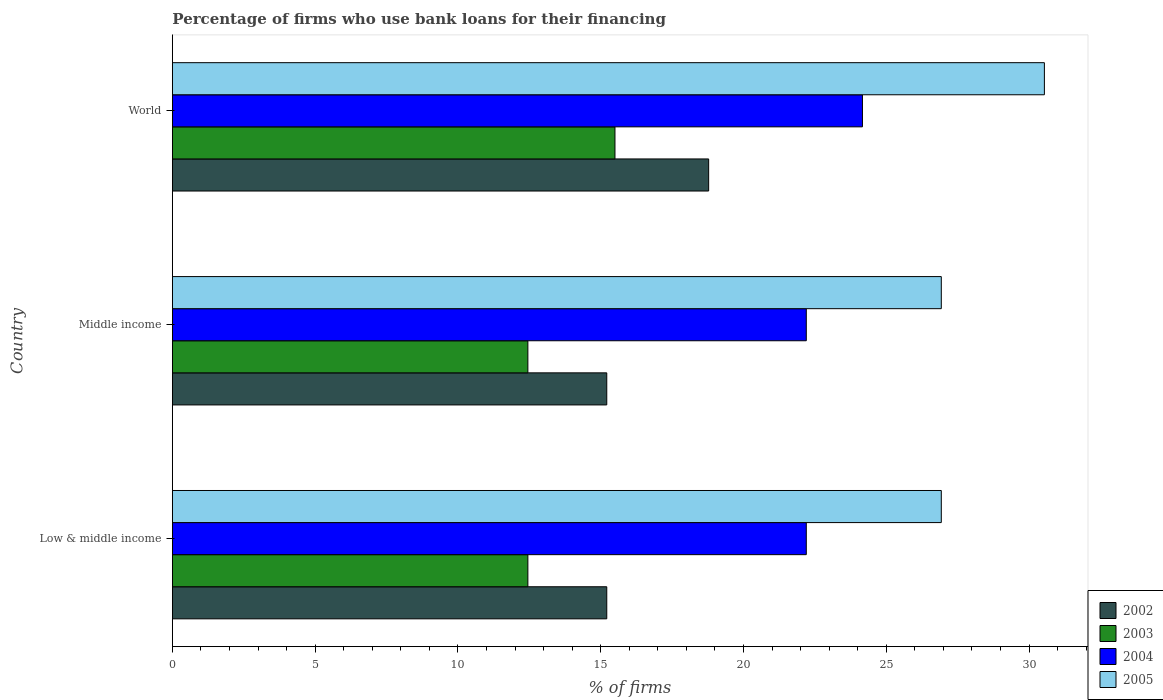How many different coloured bars are there?
Provide a short and direct response. 4. How many groups of bars are there?
Your answer should be very brief. 3. What is the label of the 2nd group of bars from the top?
Ensure brevity in your answer.  Middle income. What is the percentage of firms who use bank loans for their financing in 2002 in Middle income?
Make the answer very short. 15.21. Across all countries, what is the maximum percentage of firms who use bank loans for their financing in 2005?
Keep it short and to the point. 30.54. Across all countries, what is the minimum percentage of firms who use bank loans for their financing in 2003?
Your response must be concise. 12.45. In which country was the percentage of firms who use bank loans for their financing in 2002 maximum?
Keep it short and to the point. World. What is the total percentage of firms who use bank loans for their financing in 2005 in the graph?
Provide a succinct answer. 84.39. What is the difference between the percentage of firms who use bank loans for their financing in 2003 in Middle income and that in World?
Your answer should be compact. -3.05. What is the difference between the percentage of firms who use bank loans for their financing in 2002 in World and the percentage of firms who use bank loans for their financing in 2003 in Low & middle income?
Make the answer very short. 6.33. What is the average percentage of firms who use bank loans for their financing in 2002 per country?
Your answer should be compact. 16.4. What is the difference between the percentage of firms who use bank loans for their financing in 2002 and percentage of firms who use bank loans for their financing in 2004 in World?
Keep it short and to the point. -5.39. In how many countries, is the percentage of firms who use bank loans for their financing in 2004 greater than 17 %?
Keep it short and to the point. 3. What is the ratio of the percentage of firms who use bank loans for their financing in 2002 in Low & middle income to that in World?
Give a very brief answer. 0.81. Is the percentage of firms who use bank loans for their financing in 2005 in Low & middle income less than that in World?
Offer a terse response. Yes. Is the difference between the percentage of firms who use bank loans for their financing in 2002 in Low & middle income and Middle income greater than the difference between the percentage of firms who use bank loans for their financing in 2004 in Low & middle income and Middle income?
Your response must be concise. No. What is the difference between the highest and the second highest percentage of firms who use bank loans for their financing in 2003?
Make the answer very short. 3.05. What is the difference between the highest and the lowest percentage of firms who use bank loans for their financing in 2005?
Keep it short and to the point. 3.61. Is the sum of the percentage of firms who use bank loans for their financing in 2002 in Middle income and World greater than the maximum percentage of firms who use bank loans for their financing in 2005 across all countries?
Ensure brevity in your answer.  Yes. Is it the case that in every country, the sum of the percentage of firms who use bank loans for their financing in 2003 and percentage of firms who use bank loans for their financing in 2004 is greater than the sum of percentage of firms who use bank loans for their financing in 2002 and percentage of firms who use bank loans for their financing in 2005?
Ensure brevity in your answer.  No. Is it the case that in every country, the sum of the percentage of firms who use bank loans for their financing in 2002 and percentage of firms who use bank loans for their financing in 2005 is greater than the percentage of firms who use bank loans for their financing in 2004?
Offer a very short reply. Yes. How many bars are there?
Offer a terse response. 12. How many countries are there in the graph?
Provide a short and direct response. 3. What is the difference between two consecutive major ticks on the X-axis?
Your answer should be very brief. 5. Does the graph contain any zero values?
Your response must be concise. No. Does the graph contain grids?
Provide a short and direct response. No. Where does the legend appear in the graph?
Keep it short and to the point. Bottom right. How are the legend labels stacked?
Offer a terse response. Vertical. What is the title of the graph?
Ensure brevity in your answer.  Percentage of firms who use bank loans for their financing. What is the label or title of the X-axis?
Your answer should be compact. % of firms. What is the % of firms in 2002 in Low & middle income?
Offer a very short reply. 15.21. What is the % of firms in 2003 in Low & middle income?
Make the answer very short. 12.45. What is the % of firms in 2004 in Low & middle income?
Provide a succinct answer. 22.2. What is the % of firms of 2005 in Low & middle income?
Provide a succinct answer. 26.93. What is the % of firms in 2002 in Middle income?
Your answer should be compact. 15.21. What is the % of firms in 2003 in Middle income?
Make the answer very short. 12.45. What is the % of firms in 2005 in Middle income?
Make the answer very short. 26.93. What is the % of firms of 2002 in World?
Your response must be concise. 18.78. What is the % of firms of 2004 in World?
Your answer should be very brief. 24.17. What is the % of firms of 2005 in World?
Offer a very short reply. 30.54. Across all countries, what is the maximum % of firms of 2002?
Keep it short and to the point. 18.78. Across all countries, what is the maximum % of firms of 2004?
Offer a terse response. 24.17. Across all countries, what is the maximum % of firms of 2005?
Give a very brief answer. 30.54. Across all countries, what is the minimum % of firms in 2002?
Offer a very short reply. 15.21. Across all countries, what is the minimum % of firms of 2003?
Your answer should be very brief. 12.45. Across all countries, what is the minimum % of firms in 2004?
Provide a short and direct response. 22.2. Across all countries, what is the minimum % of firms of 2005?
Your response must be concise. 26.93. What is the total % of firms in 2002 in the graph?
Your answer should be compact. 49.21. What is the total % of firms in 2003 in the graph?
Your response must be concise. 40.4. What is the total % of firms in 2004 in the graph?
Your answer should be compact. 68.57. What is the total % of firms in 2005 in the graph?
Offer a very short reply. 84.39. What is the difference between the % of firms of 2003 in Low & middle income and that in Middle income?
Give a very brief answer. 0. What is the difference between the % of firms in 2002 in Low & middle income and that in World?
Offer a very short reply. -3.57. What is the difference between the % of firms in 2003 in Low & middle income and that in World?
Keep it short and to the point. -3.05. What is the difference between the % of firms in 2004 in Low & middle income and that in World?
Ensure brevity in your answer.  -1.97. What is the difference between the % of firms in 2005 in Low & middle income and that in World?
Provide a succinct answer. -3.61. What is the difference between the % of firms of 2002 in Middle income and that in World?
Offer a very short reply. -3.57. What is the difference between the % of firms of 2003 in Middle income and that in World?
Offer a terse response. -3.05. What is the difference between the % of firms of 2004 in Middle income and that in World?
Make the answer very short. -1.97. What is the difference between the % of firms in 2005 in Middle income and that in World?
Your answer should be compact. -3.61. What is the difference between the % of firms of 2002 in Low & middle income and the % of firms of 2003 in Middle income?
Keep it short and to the point. 2.76. What is the difference between the % of firms in 2002 in Low & middle income and the % of firms in 2004 in Middle income?
Your answer should be very brief. -6.99. What is the difference between the % of firms in 2002 in Low & middle income and the % of firms in 2005 in Middle income?
Give a very brief answer. -11.72. What is the difference between the % of firms in 2003 in Low & middle income and the % of firms in 2004 in Middle income?
Give a very brief answer. -9.75. What is the difference between the % of firms of 2003 in Low & middle income and the % of firms of 2005 in Middle income?
Provide a succinct answer. -14.48. What is the difference between the % of firms in 2004 in Low & middle income and the % of firms in 2005 in Middle income?
Give a very brief answer. -4.73. What is the difference between the % of firms in 2002 in Low & middle income and the % of firms in 2003 in World?
Offer a very short reply. -0.29. What is the difference between the % of firms in 2002 in Low & middle income and the % of firms in 2004 in World?
Make the answer very short. -8.95. What is the difference between the % of firms in 2002 in Low & middle income and the % of firms in 2005 in World?
Your answer should be compact. -15.33. What is the difference between the % of firms of 2003 in Low & middle income and the % of firms of 2004 in World?
Make the answer very short. -11.72. What is the difference between the % of firms of 2003 in Low & middle income and the % of firms of 2005 in World?
Provide a succinct answer. -18.09. What is the difference between the % of firms in 2004 in Low & middle income and the % of firms in 2005 in World?
Provide a succinct answer. -8.34. What is the difference between the % of firms in 2002 in Middle income and the % of firms in 2003 in World?
Your answer should be compact. -0.29. What is the difference between the % of firms of 2002 in Middle income and the % of firms of 2004 in World?
Give a very brief answer. -8.95. What is the difference between the % of firms in 2002 in Middle income and the % of firms in 2005 in World?
Make the answer very short. -15.33. What is the difference between the % of firms of 2003 in Middle income and the % of firms of 2004 in World?
Provide a short and direct response. -11.72. What is the difference between the % of firms in 2003 in Middle income and the % of firms in 2005 in World?
Make the answer very short. -18.09. What is the difference between the % of firms in 2004 in Middle income and the % of firms in 2005 in World?
Provide a succinct answer. -8.34. What is the average % of firms in 2002 per country?
Your answer should be compact. 16.4. What is the average % of firms of 2003 per country?
Your answer should be very brief. 13.47. What is the average % of firms of 2004 per country?
Keep it short and to the point. 22.86. What is the average % of firms of 2005 per country?
Offer a terse response. 28.13. What is the difference between the % of firms of 2002 and % of firms of 2003 in Low & middle income?
Keep it short and to the point. 2.76. What is the difference between the % of firms in 2002 and % of firms in 2004 in Low & middle income?
Offer a terse response. -6.99. What is the difference between the % of firms in 2002 and % of firms in 2005 in Low & middle income?
Keep it short and to the point. -11.72. What is the difference between the % of firms of 2003 and % of firms of 2004 in Low & middle income?
Give a very brief answer. -9.75. What is the difference between the % of firms of 2003 and % of firms of 2005 in Low & middle income?
Your response must be concise. -14.48. What is the difference between the % of firms of 2004 and % of firms of 2005 in Low & middle income?
Provide a succinct answer. -4.73. What is the difference between the % of firms of 2002 and % of firms of 2003 in Middle income?
Give a very brief answer. 2.76. What is the difference between the % of firms in 2002 and % of firms in 2004 in Middle income?
Provide a short and direct response. -6.99. What is the difference between the % of firms in 2002 and % of firms in 2005 in Middle income?
Offer a terse response. -11.72. What is the difference between the % of firms of 2003 and % of firms of 2004 in Middle income?
Provide a succinct answer. -9.75. What is the difference between the % of firms of 2003 and % of firms of 2005 in Middle income?
Provide a succinct answer. -14.48. What is the difference between the % of firms in 2004 and % of firms in 2005 in Middle income?
Make the answer very short. -4.73. What is the difference between the % of firms in 2002 and % of firms in 2003 in World?
Provide a short and direct response. 3.28. What is the difference between the % of firms of 2002 and % of firms of 2004 in World?
Give a very brief answer. -5.39. What is the difference between the % of firms in 2002 and % of firms in 2005 in World?
Keep it short and to the point. -11.76. What is the difference between the % of firms of 2003 and % of firms of 2004 in World?
Your answer should be very brief. -8.67. What is the difference between the % of firms in 2003 and % of firms in 2005 in World?
Your answer should be very brief. -15.04. What is the difference between the % of firms of 2004 and % of firms of 2005 in World?
Offer a very short reply. -6.37. What is the ratio of the % of firms in 2002 in Low & middle income to that in Middle income?
Provide a short and direct response. 1. What is the ratio of the % of firms of 2003 in Low & middle income to that in Middle income?
Give a very brief answer. 1. What is the ratio of the % of firms in 2004 in Low & middle income to that in Middle income?
Offer a terse response. 1. What is the ratio of the % of firms in 2002 in Low & middle income to that in World?
Give a very brief answer. 0.81. What is the ratio of the % of firms of 2003 in Low & middle income to that in World?
Make the answer very short. 0.8. What is the ratio of the % of firms in 2004 in Low & middle income to that in World?
Give a very brief answer. 0.92. What is the ratio of the % of firms of 2005 in Low & middle income to that in World?
Offer a terse response. 0.88. What is the ratio of the % of firms in 2002 in Middle income to that in World?
Keep it short and to the point. 0.81. What is the ratio of the % of firms in 2003 in Middle income to that in World?
Offer a very short reply. 0.8. What is the ratio of the % of firms in 2004 in Middle income to that in World?
Your answer should be compact. 0.92. What is the ratio of the % of firms in 2005 in Middle income to that in World?
Your response must be concise. 0.88. What is the difference between the highest and the second highest % of firms of 2002?
Your response must be concise. 3.57. What is the difference between the highest and the second highest % of firms in 2003?
Provide a succinct answer. 3.05. What is the difference between the highest and the second highest % of firms of 2004?
Your answer should be compact. 1.97. What is the difference between the highest and the second highest % of firms in 2005?
Make the answer very short. 3.61. What is the difference between the highest and the lowest % of firms of 2002?
Make the answer very short. 3.57. What is the difference between the highest and the lowest % of firms of 2003?
Offer a very short reply. 3.05. What is the difference between the highest and the lowest % of firms in 2004?
Offer a terse response. 1.97. What is the difference between the highest and the lowest % of firms in 2005?
Make the answer very short. 3.61. 